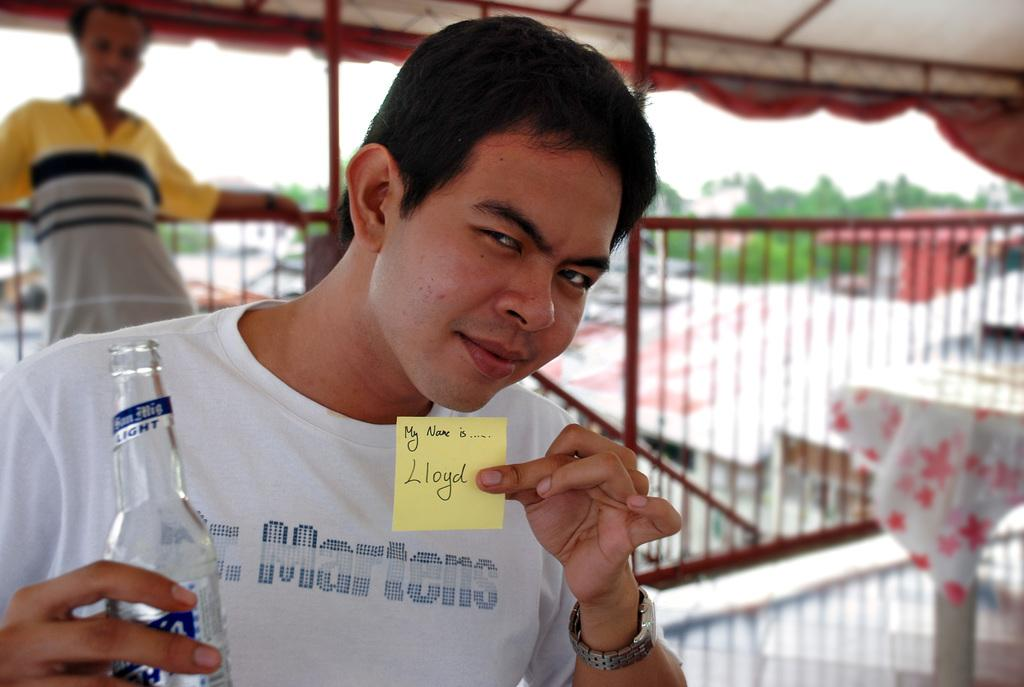What is the person holding in their hand in the image? The person is holding a note and a bottle in their hand. How far away is the person from the observer in the image? The person is standing far from the observer in the image. What can be seen in the background of the image? There are multiple trees visible in the image. What type of quill is the person using to write on the note in the image? There is no quill visible in the image, and the person is not writing on the note. 